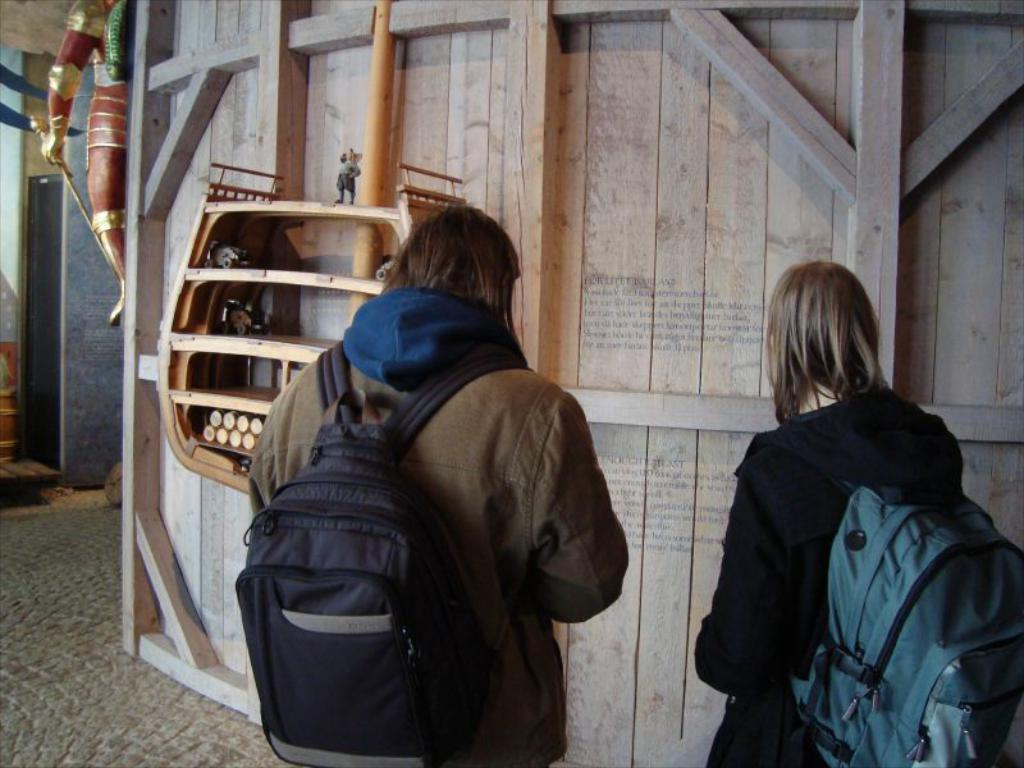How many persons are in the image? There are persons in the image. What are the persons wearing? The persons are wearing jackets. What are the persons carrying? The persons are carrying bags. What are the persons doing in the image? The persons are standing. What type of structure can be seen in the image? There is a wooden wall in the image. What other objects can be seen in the image? There is a pole, racks, a statue, and a box in the image. What is the taste of the statue in the image? The statue is not an edible object, so it does not have a taste. 